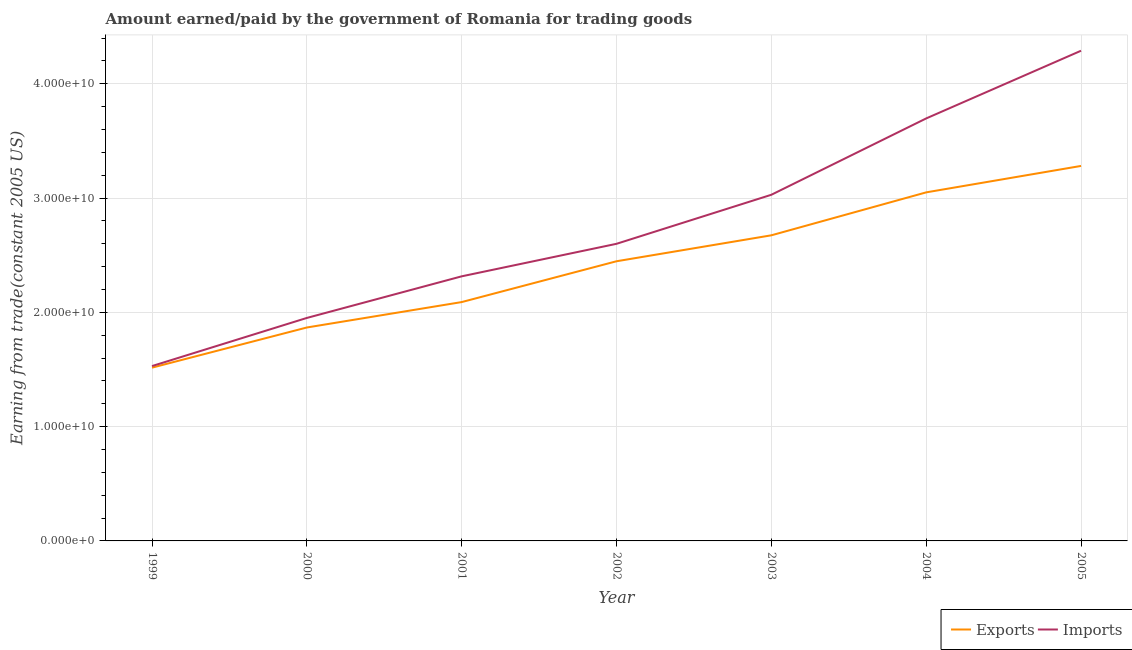Does the line corresponding to amount earned from exports intersect with the line corresponding to amount paid for imports?
Provide a short and direct response. No. Is the number of lines equal to the number of legend labels?
Your response must be concise. Yes. What is the amount earned from exports in 2001?
Provide a short and direct response. 2.09e+1. Across all years, what is the maximum amount earned from exports?
Your answer should be compact. 3.28e+1. Across all years, what is the minimum amount paid for imports?
Make the answer very short. 1.53e+1. In which year was the amount earned from exports maximum?
Give a very brief answer. 2005. In which year was the amount paid for imports minimum?
Make the answer very short. 1999. What is the total amount earned from exports in the graph?
Keep it short and to the point. 1.69e+11. What is the difference between the amount paid for imports in 2003 and that in 2004?
Ensure brevity in your answer.  -6.68e+09. What is the difference between the amount earned from exports in 2004 and the amount paid for imports in 2001?
Offer a terse response. 7.35e+09. What is the average amount paid for imports per year?
Offer a very short reply. 2.77e+1. In the year 2002, what is the difference between the amount paid for imports and amount earned from exports?
Your answer should be compact. 1.53e+09. In how many years, is the amount earned from exports greater than 8000000000 US$?
Keep it short and to the point. 7. What is the ratio of the amount earned from exports in 2000 to that in 2003?
Keep it short and to the point. 0.7. Is the amount earned from exports in 2001 less than that in 2004?
Your response must be concise. Yes. What is the difference between the highest and the second highest amount paid for imports?
Your answer should be very brief. 5.92e+09. What is the difference between the highest and the lowest amount earned from exports?
Give a very brief answer. 1.76e+1. Does the amount paid for imports monotonically increase over the years?
Give a very brief answer. Yes. Is the amount paid for imports strictly greater than the amount earned from exports over the years?
Keep it short and to the point. Yes. How many years are there in the graph?
Keep it short and to the point. 7. What is the difference between two consecutive major ticks on the Y-axis?
Offer a terse response. 1.00e+1. Are the values on the major ticks of Y-axis written in scientific E-notation?
Your answer should be very brief. Yes. Does the graph contain grids?
Your response must be concise. Yes. Where does the legend appear in the graph?
Provide a succinct answer. Bottom right. How many legend labels are there?
Make the answer very short. 2. What is the title of the graph?
Offer a very short reply. Amount earned/paid by the government of Romania for trading goods. What is the label or title of the X-axis?
Make the answer very short. Year. What is the label or title of the Y-axis?
Ensure brevity in your answer.  Earning from trade(constant 2005 US). What is the Earning from trade(constant 2005 US) in Exports in 1999?
Keep it short and to the point. 1.52e+1. What is the Earning from trade(constant 2005 US) in Imports in 1999?
Your answer should be very brief. 1.53e+1. What is the Earning from trade(constant 2005 US) in Exports in 2000?
Give a very brief answer. 1.87e+1. What is the Earning from trade(constant 2005 US) in Imports in 2000?
Give a very brief answer. 1.95e+1. What is the Earning from trade(constant 2005 US) in Exports in 2001?
Provide a succinct answer. 2.09e+1. What is the Earning from trade(constant 2005 US) of Imports in 2001?
Give a very brief answer. 2.32e+1. What is the Earning from trade(constant 2005 US) in Exports in 2002?
Offer a very short reply. 2.45e+1. What is the Earning from trade(constant 2005 US) of Imports in 2002?
Make the answer very short. 2.60e+1. What is the Earning from trade(constant 2005 US) of Exports in 2003?
Your answer should be compact. 2.67e+1. What is the Earning from trade(constant 2005 US) in Imports in 2003?
Your response must be concise. 3.03e+1. What is the Earning from trade(constant 2005 US) of Exports in 2004?
Make the answer very short. 3.05e+1. What is the Earning from trade(constant 2005 US) of Imports in 2004?
Your answer should be compact. 3.70e+1. What is the Earning from trade(constant 2005 US) in Exports in 2005?
Provide a succinct answer. 3.28e+1. What is the Earning from trade(constant 2005 US) of Imports in 2005?
Your answer should be compact. 4.29e+1. Across all years, what is the maximum Earning from trade(constant 2005 US) of Exports?
Offer a terse response. 3.28e+1. Across all years, what is the maximum Earning from trade(constant 2005 US) in Imports?
Offer a very short reply. 4.29e+1. Across all years, what is the minimum Earning from trade(constant 2005 US) in Exports?
Your answer should be very brief. 1.52e+1. Across all years, what is the minimum Earning from trade(constant 2005 US) in Imports?
Make the answer very short. 1.53e+1. What is the total Earning from trade(constant 2005 US) of Exports in the graph?
Make the answer very short. 1.69e+11. What is the total Earning from trade(constant 2005 US) of Imports in the graph?
Give a very brief answer. 1.94e+11. What is the difference between the Earning from trade(constant 2005 US) in Exports in 1999 and that in 2000?
Offer a very short reply. -3.51e+09. What is the difference between the Earning from trade(constant 2005 US) of Imports in 1999 and that in 2000?
Your answer should be very brief. -4.21e+09. What is the difference between the Earning from trade(constant 2005 US) of Exports in 1999 and that in 2001?
Give a very brief answer. -5.74e+09. What is the difference between the Earning from trade(constant 2005 US) of Imports in 1999 and that in 2001?
Your answer should be compact. -7.85e+09. What is the difference between the Earning from trade(constant 2005 US) in Exports in 1999 and that in 2002?
Offer a very short reply. -9.31e+09. What is the difference between the Earning from trade(constant 2005 US) in Imports in 1999 and that in 2002?
Offer a very short reply. -1.07e+1. What is the difference between the Earning from trade(constant 2005 US) of Exports in 1999 and that in 2003?
Your answer should be compact. -1.16e+1. What is the difference between the Earning from trade(constant 2005 US) of Imports in 1999 and that in 2003?
Provide a succinct answer. -1.50e+1. What is the difference between the Earning from trade(constant 2005 US) of Exports in 1999 and that in 2004?
Offer a terse response. -1.53e+1. What is the difference between the Earning from trade(constant 2005 US) in Imports in 1999 and that in 2004?
Make the answer very short. -2.17e+1. What is the difference between the Earning from trade(constant 2005 US) of Exports in 1999 and that in 2005?
Offer a very short reply. -1.76e+1. What is the difference between the Earning from trade(constant 2005 US) of Imports in 1999 and that in 2005?
Give a very brief answer. -2.76e+1. What is the difference between the Earning from trade(constant 2005 US) of Exports in 2000 and that in 2001?
Offer a very short reply. -2.22e+09. What is the difference between the Earning from trade(constant 2005 US) in Imports in 2000 and that in 2001?
Your answer should be very brief. -3.64e+09. What is the difference between the Earning from trade(constant 2005 US) of Exports in 2000 and that in 2002?
Give a very brief answer. -5.80e+09. What is the difference between the Earning from trade(constant 2005 US) in Imports in 2000 and that in 2002?
Give a very brief answer. -6.49e+09. What is the difference between the Earning from trade(constant 2005 US) of Exports in 2000 and that in 2003?
Your answer should be very brief. -8.07e+09. What is the difference between the Earning from trade(constant 2005 US) of Imports in 2000 and that in 2003?
Make the answer very short. -1.08e+1. What is the difference between the Earning from trade(constant 2005 US) of Exports in 2000 and that in 2004?
Provide a succinct answer. -1.18e+1. What is the difference between the Earning from trade(constant 2005 US) of Imports in 2000 and that in 2004?
Offer a terse response. -1.75e+1. What is the difference between the Earning from trade(constant 2005 US) in Exports in 2000 and that in 2005?
Your response must be concise. -1.41e+1. What is the difference between the Earning from trade(constant 2005 US) in Imports in 2000 and that in 2005?
Your answer should be compact. -2.34e+1. What is the difference between the Earning from trade(constant 2005 US) in Exports in 2001 and that in 2002?
Make the answer very short. -3.57e+09. What is the difference between the Earning from trade(constant 2005 US) in Imports in 2001 and that in 2002?
Offer a terse response. -2.85e+09. What is the difference between the Earning from trade(constant 2005 US) in Exports in 2001 and that in 2003?
Offer a terse response. -5.84e+09. What is the difference between the Earning from trade(constant 2005 US) of Imports in 2001 and that in 2003?
Your answer should be compact. -7.14e+09. What is the difference between the Earning from trade(constant 2005 US) of Exports in 2001 and that in 2004?
Offer a terse response. -9.60e+09. What is the difference between the Earning from trade(constant 2005 US) of Imports in 2001 and that in 2004?
Provide a succinct answer. -1.38e+1. What is the difference between the Earning from trade(constant 2005 US) of Exports in 2001 and that in 2005?
Your response must be concise. -1.19e+1. What is the difference between the Earning from trade(constant 2005 US) of Imports in 2001 and that in 2005?
Your answer should be compact. -1.97e+1. What is the difference between the Earning from trade(constant 2005 US) of Exports in 2002 and that in 2003?
Your answer should be compact. -2.27e+09. What is the difference between the Earning from trade(constant 2005 US) in Imports in 2002 and that in 2003?
Provide a succinct answer. -4.29e+09. What is the difference between the Earning from trade(constant 2005 US) of Exports in 2002 and that in 2004?
Keep it short and to the point. -6.03e+09. What is the difference between the Earning from trade(constant 2005 US) in Imports in 2002 and that in 2004?
Offer a very short reply. -1.10e+1. What is the difference between the Earning from trade(constant 2005 US) of Exports in 2002 and that in 2005?
Provide a short and direct response. -8.34e+09. What is the difference between the Earning from trade(constant 2005 US) in Imports in 2002 and that in 2005?
Make the answer very short. -1.69e+1. What is the difference between the Earning from trade(constant 2005 US) in Exports in 2003 and that in 2004?
Provide a succinct answer. -3.76e+09. What is the difference between the Earning from trade(constant 2005 US) in Imports in 2003 and that in 2004?
Offer a terse response. -6.68e+09. What is the difference between the Earning from trade(constant 2005 US) in Exports in 2003 and that in 2005?
Your response must be concise. -6.07e+09. What is the difference between the Earning from trade(constant 2005 US) in Imports in 2003 and that in 2005?
Give a very brief answer. -1.26e+1. What is the difference between the Earning from trade(constant 2005 US) in Exports in 2004 and that in 2005?
Make the answer very short. -2.31e+09. What is the difference between the Earning from trade(constant 2005 US) in Imports in 2004 and that in 2005?
Provide a succinct answer. -5.92e+09. What is the difference between the Earning from trade(constant 2005 US) in Exports in 1999 and the Earning from trade(constant 2005 US) in Imports in 2000?
Ensure brevity in your answer.  -4.35e+09. What is the difference between the Earning from trade(constant 2005 US) of Exports in 1999 and the Earning from trade(constant 2005 US) of Imports in 2001?
Offer a terse response. -7.99e+09. What is the difference between the Earning from trade(constant 2005 US) of Exports in 1999 and the Earning from trade(constant 2005 US) of Imports in 2002?
Offer a very short reply. -1.08e+1. What is the difference between the Earning from trade(constant 2005 US) in Exports in 1999 and the Earning from trade(constant 2005 US) in Imports in 2003?
Ensure brevity in your answer.  -1.51e+1. What is the difference between the Earning from trade(constant 2005 US) in Exports in 1999 and the Earning from trade(constant 2005 US) in Imports in 2004?
Ensure brevity in your answer.  -2.18e+1. What is the difference between the Earning from trade(constant 2005 US) in Exports in 1999 and the Earning from trade(constant 2005 US) in Imports in 2005?
Your answer should be compact. -2.77e+1. What is the difference between the Earning from trade(constant 2005 US) in Exports in 2000 and the Earning from trade(constant 2005 US) in Imports in 2001?
Your answer should be compact. -4.48e+09. What is the difference between the Earning from trade(constant 2005 US) of Exports in 2000 and the Earning from trade(constant 2005 US) of Imports in 2002?
Offer a very short reply. -7.32e+09. What is the difference between the Earning from trade(constant 2005 US) in Exports in 2000 and the Earning from trade(constant 2005 US) in Imports in 2003?
Your response must be concise. -1.16e+1. What is the difference between the Earning from trade(constant 2005 US) in Exports in 2000 and the Earning from trade(constant 2005 US) in Imports in 2004?
Provide a short and direct response. -1.83e+1. What is the difference between the Earning from trade(constant 2005 US) in Exports in 2000 and the Earning from trade(constant 2005 US) in Imports in 2005?
Make the answer very short. -2.42e+1. What is the difference between the Earning from trade(constant 2005 US) in Exports in 2001 and the Earning from trade(constant 2005 US) in Imports in 2002?
Your answer should be compact. -5.10e+09. What is the difference between the Earning from trade(constant 2005 US) of Exports in 2001 and the Earning from trade(constant 2005 US) of Imports in 2003?
Provide a succinct answer. -9.39e+09. What is the difference between the Earning from trade(constant 2005 US) in Exports in 2001 and the Earning from trade(constant 2005 US) in Imports in 2004?
Provide a short and direct response. -1.61e+1. What is the difference between the Earning from trade(constant 2005 US) in Exports in 2001 and the Earning from trade(constant 2005 US) in Imports in 2005?
Offer a terse response. -2.20e+1. What is the difference between the Earning from trade(constant 2005 US) in Exports in 2002 and the Earning from trade(constant 2005 US) in Imports in 2003?
Give a very brief answer. -5.82e+09. What is the difference between the Earning from trade(constant 2005 US) in Exports in 2002 and the Earning from trade(constant 2005 US) in Imports in 2004?
Your answer should be compact. -1.25e+1. What is the difference between the Earning from trade(constant 2005 US) in Exports in 2002 and the Earning from trade(constant 2005 US) in Imports in 2005?
Make the answer very short. -1.84e+1. What is the difference between the Earning from trade(constant 2005 US) of Exports in 2003 and the Earning from trade(constant 2005 US) of Imports in 2004?
Make the answer very short. -1.02e+1. What is the difference between the Earning from trade(constant 2005 US) of Exports in 2003 and the Earning from trade(constant 2005 US) of Imports in 2005?
Offer a very short reply. -1.61e+1. What is the difference between the Earning from trade(constant 2005 US) of Exports in 2004 and the Earning from trade(constant 2005 US) of Imports in 2005?
Keep it short and to the point. -1.24e+1. What is the average Earning from trade(constant 2005 US) of Exports per year?
Provide a short and direct response. 2.42e+1. What is the average Earning from trade(constant 2005 US) of Imports per year?
Your answer should be compact. 2.77e+1. In the year 1999, what is the difference between the Earning from trade(constant 2005 US) of Exports and Earning from trade(constant 2005 US) of Imports?
Ensure brevity in your answer.  -1.39e+08. In the year 2000, what is the difference between the Earning from trade(constant 2005 US) of Exports and Earning from trade(constant 2005 US) of Imports?
Offer a very short reply. -8.36e+08. In the year 2001, what is the difference between the Earning from trade(constant 2005 US) in Exports and Earning from trade(constant 2005 US) in Imports?
Give a very brief answer. -2.25e+09. In the year 2002, what is the difference between the Earning from trade(constant 2005 US) in Exports and Earning from trade(constant 2005 US) in Imports?
Your response must be concise. -1.53e+09. In the year 2003, what is the difference between the Earning from trade(constant 2005 US) of Exports and Earning from trade(constant 2005 US) of Imports?
Your answer should be compact. -3.55e+09. In the year 2004, what is the difference between the Earning from trade(constant 2005 US) of Exports and Earning from trade(constant 2005 US) of Imports?
Keep it short and to the point. -6.47e+09. In the year 2005, what is the difference between the Earning from trade(constant 2005 US) of Exports and Earning from trade(constant 2005 US) of Imports?
Ensure brevity in your answer.  -1.01e+1. What is the ratio of the Earning from trade(constant 2005 US) of Exports in 1999 to that in 2000?
Offer a terse response. 0.81. What is the ratio of the Earning from trade(constant 2005 US) of Imports in 1999 to that in 2000?
Your answer should be compact. 0.78. What is the ratio of the Earning from trade(constant 2005 US) of Exports in 1999 to that in 2001?
Your answer should be very brief. 0.73. What is the ratio of the Earning from trade(constant 2005 US) of Imports in 1999 to that in 2001?
Make the answer very short. 0.66. What is the ratio of the Earning from trade(constant 2005 US) of Exports in 1999 to that in 2002?
Make the answer very short. 0.62. What is the ratio of the Earning from trade(constant 2005 US) of Imports in 1999 to that in 2002?
Offer a terse response. 0.59. What is the ratio of the Earning from trade(constant 2005 US) of Exports in 1999 to that in 2003?
Your answer should be compact. 0.57. What is the ratio of the Earning from trade(constant 2005 US) of Imports in 1999 to that in 2003?
Offer a terse response. 0.51. What is the ratio of the Earning from trade(constant 2005 US) in Exports in 1999 to that in 2004?
Your response must be concise. 0.5. What is the ratio of the Earning from trade(constant 2005 US) in Imports in 1999 to that in 2004?
Your response must be concise. 0.41. What is the ratio of the Earning from trade(constant 2005 US) of Exports in 1999 to that in 2005?
Offer a very short reply. 0.46. What is the ratio of the Earning from trade(constant 2005 US) in Imports in 1999 to that in 2005?
Make the answer very short. 0.36. What is the ratio of the Earning from trade(constant 2005 US) of Exports in 2000 to that in 2001?
Provide a short and direct response. 0.89. What is the ratio of the Earning from trade(constant 2005 US) of Imports in 2000 to that in 2001?
Offer a terse response. 0.84. What is the ratio of the Earning from trade(constant 2005 US) in Exports in 2000 to that in 2002?
Ensure brevity in your answer.  0.76. What is the ratio of the Earning from trade(constant 2005 US) in Imports in 2000 to that in 2002?
Ensure brevity in your answer.  0.75. What is the ratio of the Earning from trade(constant 2005 US) of Exports in 2000 to that in 2003?
Keep it short and to the point. 0.7. What is the ratio of the Earning from trade(constant 2005 US) in Imports in 2000 to that in 2003?
Offer a very short reply. 0.64. What is the ratio of the Earning from trade(constant 2005 US) of Exports in 2000 to that in 2004?
Your answer should be very brief. 0.61. What is the ratio of the Earning from trade(constant 2005 US) in Imports in 2000 to that in 2004?
Your answer should be very brief. 0.53. What is the ratio of the Earning from trade(constant 2005 US) in Exports in 2000 to that in 2005?
Make the answer very short. 0.57. What is the ratio of the Earning from trade(constant 2005 US) in Imports in 2000 to that in 2005?
Your response must be concise. 0.45. What is the ratio of the Earning from trade(constant 2005 US) in Exports in 2001 to that in 2002?
Your response must be concise. 0.85. What is the ratio of the Earning from trade(constant 2005 US) in Imports in 2001 to that in 2002?
Ensure brevity in your answer.  0.89. What is the ratio of the Earning from trade(constant 2005 US) in Exports in 2001 to that in 2003?
Provide a short and direct response. 0.78. What is the ratio of the Earning from trade(constant 2005 US) in Imports in 2001 to that in 2003?
Offer a very short reply. 0.76. What is the ratio of the Earning from trade(constant 2005 US) in Exports in 2001 to that in 2004?
Keep it short and to the point. 0.69. What is the ratio of the Earning from trade(constant 2005 US) of Imports in 2001 to that in 2004?
Make the answer very short. 0.63. What is the ratio of the Earning from trade(constant 2005 US) of Exports in 2001 to that in 2005?
Your answer should be very brief. 0.64. What is the ratio of the Earning from trade(constant 2005 US) in Imports in 2001 to that in 2005?
Provide a short and direct response. 0.54. What is the ratio of the Earning from trade(constant 2005 US) in Exports in 2002 to that in 2003?
Provide a succinct answer. 0.92. What is the ratio of the Earning from trade(constant 2005 US) of Imports in 2002 to that in 2003?
Provide a short and direct response. 0.86. What is the ratio of the Earning from trade(constant 2005 US) of Exports in 2002 to that in 2004?
Offer a terse response. 0.8. What is the ratio of the Earning from trade(constant 2005 US) in Imports in 2002 to that in 2004?
Offer a terse response. 0.7. What is the ratio of the Earning from trade(constant 2005 US) of Exports in 2002 to that in 2005?
Ensure brevity in your answer.  0.75. What is the ratio of the Earning from trade(constant 2005 US) in Imports in 2002 to that in 2005?
Provide a succinct answer. 0.61. What is the ratio of the Earning from trade(constant 2005 US) of Exports in 2003 to that in 2004?
Offer a terse response. 0.88. What is the ratio of the Earning from trade(constant 2005 US) of Imports in 2003 to that in 2004?
Provide a short and direct response. 0.82. What is the ratio of the Earning from trade(constant 2005 US) of Exports in 2003 to that in 2005?
Offer a very short reply. 0.81. What is the ratio of the Earning from trade(constant 2005 US) in Imports in 2003 to that in 2005?
Offer a very short reply. 0.71. What is the ratio of the Earning from trade(constant 2005 US) in Exports in 2004 to that in 2005?
Offer a terse response. 0.93. What is the ratio of the Earning from trade(constant 2005 US) in Imports in 2004 to that in 2005?
Ensure brevity in your answer.  0.86. What is the difference between the highest and the second highest Earning from trade(constant 2005 US) of Exports?
Keep it short and to the point. 2.31e+09. What is the difference between the highest and the second highest Earning from trade(constant 2005 US) in Imports?
Ensure brevity in your answer.  5.92e+09. What is the difference between the highest and the lowest Earning from trade(constant 2005 US) in Exports?
Your answer should be compact. 1.76e+1. What is the difference between the highest and the lowest Earning from trade(constant 2005 US) of Imports?
Your response must be concise. 2.76e+1. 